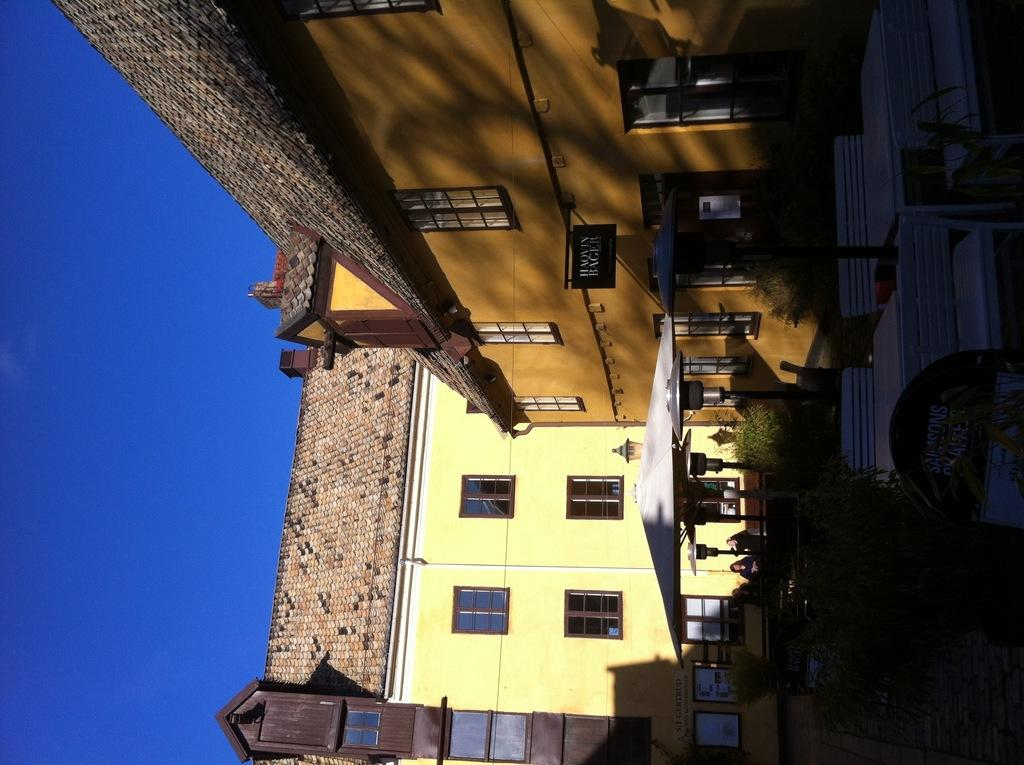What type of furniture is present in the image? There are tables and chairs in the image. What other objects can be seen in the image? There are poles, trees, and buildings with windows in the image. How many people are visible in the image? There are three persons in the image. What is visible in the background of the image? The sky is visible in the background of the image. Can you see any feathers floating in the air in the image? There are no feathers visible in the image. What type of harmony is being played by the three persons in the image? There is no indication of music or harmony in the image; it only shows three people, tables, chairs, poles, trees, buildings, and the sky. 